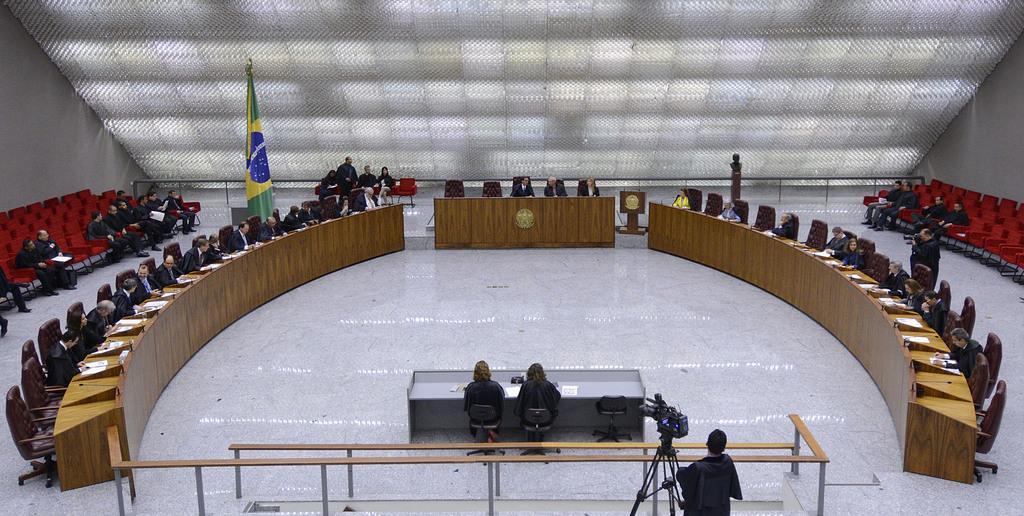Can you describe this image briefly? In this image, there are a few people. We can see some tables with objects like posters and microphones. We can see some chairs and the fence. We can see a flag and the wall. We can also see some wooden objects and a camera with a camera stand. We can see the roof. 